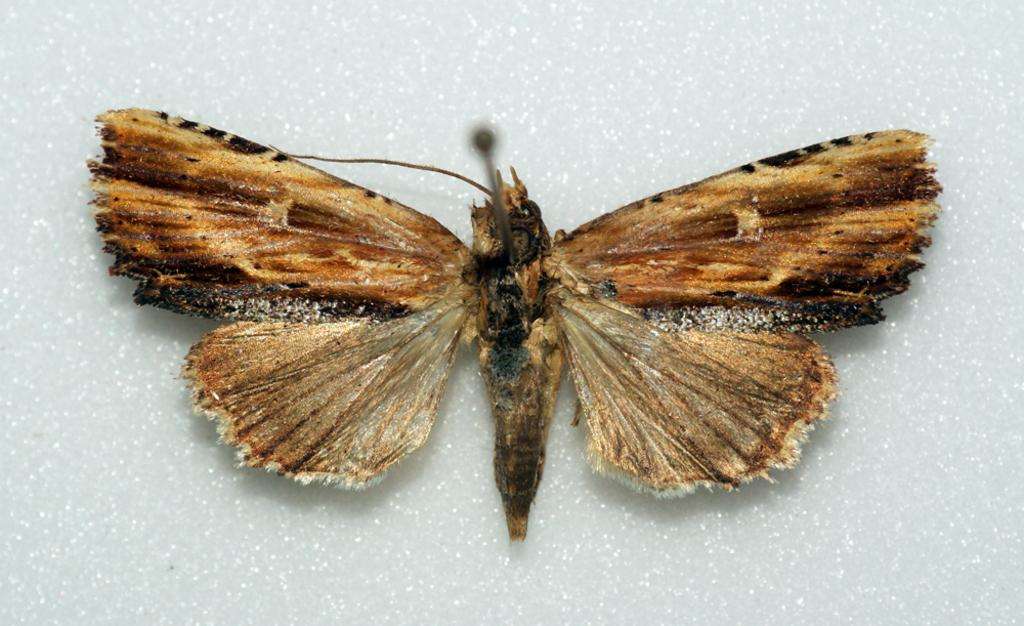What is the main subject in the center of the image? There is a butterfly in the center of the image. Where is the butterfly located? The butterfly is present on the wall. What time of day is it in the image? The time of day cannot be determined from the image, as there are no indications of time. What type of surface is the butterfly on in the image? The butterfly is on the wall, not on a sidewalk or any other type of surface. 